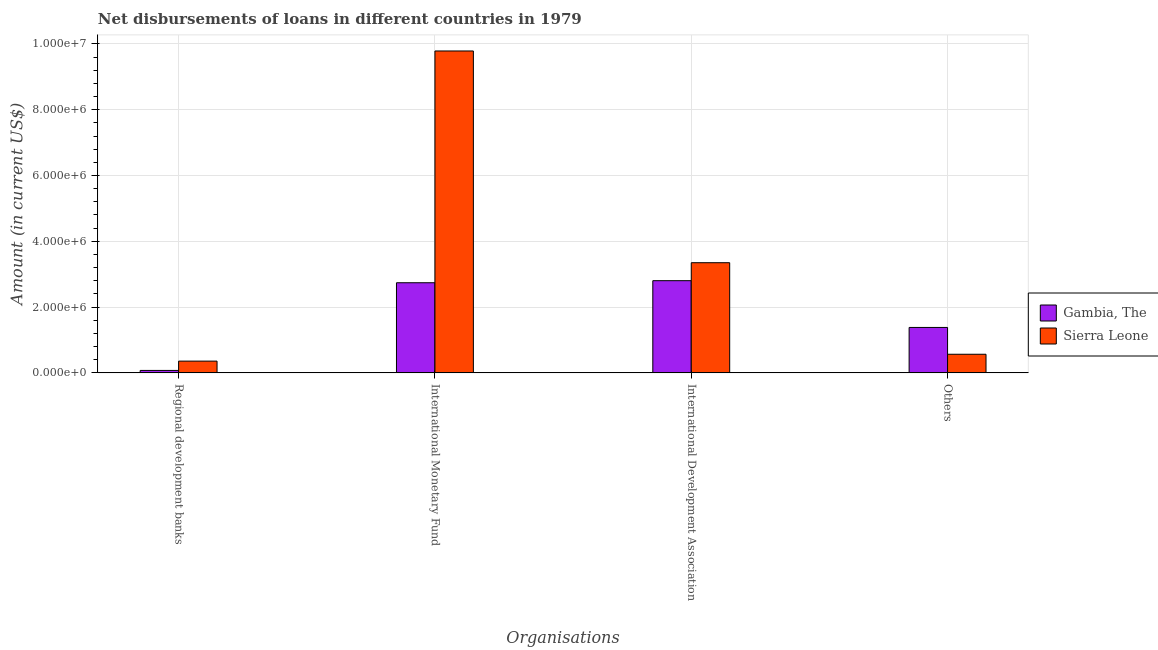Are the number of bars on each tick of the X-axis equal?
Give a very brief answer. Yes. How many bars are there on the 1st tick from the left?
Offer a terse response. 2. What is the label of the 4th group of bars from the left?
Ensure brevity in your answer.  Others. What is the amount of loan disimbursed by regional development banks in Gambia, The?
Your answer should be very brief. 7.40e+04. Across all countries, what is the maximum amount of loan disimbursed by international monetary fund?
Ensure brevity in your answer.  9.79e+06. Across all countries, what is the minimum amount of loan disimbursed by other organisations?
Your answer should be compact. 5.66e+05. In which country was the amount of loan disimbursed by international monetary fund maximum?
Offer a terse response. Sierra Leone. In which country was the amount of loan disimbursed by international monetary fund minimum?
Your response must be concise. Gambia, The. What is the total amount of loan disimbursed by international monetary fund in the graph?
Give a very brief answer. 1.25e+07. What is the difference between the amount of loan disimbursed by international development association in Gambia, The and that in Sierra Leone?
Give a very brief answer. -5.46e+05. What is the difference between the amount of loan disimbursed by international development association in Gambia, The and the amount of loan disimbursed by international monetary fund in Sierra Leone?
Offer a very short reply. -6.98e+06. What is the average amount of loan disimbursed by international development association per country?
Your response must be concise. 3.08e+06. What is the difference between the amount of loan disimbursed by international development association and amount of loan disimbursed by regional development banks in Sierra Leone?
Give a very brief answer. 2.99e+06. What is the ratio of the amount of loan disimbursed by international monetary fund in Gambia, The to that in Sierra Leone?
Ensure brevity in your answer.  0.28. Is the difference between the amount of loan disimbursed by international monetary fund in Sierra Leone and Gambia, The greater than the difference between the amount of loan disimbursed by regional development banks in Sierra Leone and Gambia, The?
Offer a very short reply. Yes. What is the difference between the highest and the second highest amount of loan disimbursed by international monetary fund?
Offer a very short reply. 7.05e+06. What is the difference between the highest and the lowest amount of loan disimbursed by other organisations?
Make the answer very short. 8.15e+05. Is it the case that in every country, the sum of the amount of loan disimbursed by regional development banks and amount of loan disimbursed by international monetary fund is greater than the sum of amount of loan disimbursed by other organisations and amount of loan disimbursed by international development association?
Give a very brief answer. Yes. What does the 2nd bar from the left in Others represents?
Offer a very short reply. Sierra Leone. What does the 1st bar from the right in Others represents?
Offer a very short reply. Sierra Leone. How many bars are there?
Give a very brief answer. 8. Are the values on the major ticks of Y-axis written in scientific E-notation?
Keep it short and to the point. Yes. How many legend labels are there?
Your response must be concise. 2. What is the title of the graph?
Your answer should be compact. Net disbursements of loans in different countries in 1979. Does "Panama" appear as one of the legend labels in the graph?
Give a very brief answer. No. What is the label or title of the X-axis?
Give a very brief answer. Organisations. What is the label or title of the Y-axis?
Make the answer very short. Amount (in current US$). What is the Amount (in current US$) in Gambia, The in Regional development banks?
Your answer should be very brief. 7.40e+04. What is the Amount (in current US$) of Sierra Leone in Regional development banks?
Offer a very short reply. 3.57e+05. What is the Amount (in current US$) in Gambia, The in International Monetary Fund?
Make the answer very short. 2.74e+06. What is the Amount (in current US$) of Sierra Leone in International Monetary Fund?
Offer a very short reply. 9.79e+06. What is the Amount (in current US$) in Gambia, The in International Development Association?
Your answer should be very brief. 2.80e+06. What is the Amount (in current US$) in Sierra Leone in International Development Association?
Offer a very short reply. 3.35e+06. What is the Amount (in current US$) of Gambia, The in Others?
Your answer should be compact. 1.38e+06. What is the Amount (in current US$) in Sierra Leone in Others?
Your response must be concise. 5.66e+05. Across all Organisations, what is the maximum Amount (in current US$) of Gambia, The?
Your response must be concise. 2.80e+06. Across all Organisations, what is the maximum Amount (in current US$) in Sierra Leone?
Make the answer very short. 9.79e+06. Across all Organisations, what is the minimum Amount (in current US$) in Gambia, The?
Offer a terse response. 7.40e+04. Across all Organisations, what is the minimum Amount (in current US$) in Sierra Leone?
Your answer should be compact. 3.57e+05. What is the total Amount (in current US$) of Gambia, The in the graph?
Provide a short and direct response. 7.00e+06. What is the total Amount (in current US$) in Sierra Leone in the graph?
Give a very brief answer. 1.41e+07. What is the difference between the Amount (in current US$) of Gambia, The in Regional development banks and that in International Monetary Fund?
Keep it short and to the point. -2.67e+06. What is the difference between the Amount (in current US$) of Sierra Leone in Regional development banks and that in International Monetary Fund?
Your answer should be very brief. -9.43e+06. What is the difference between the Amount (in current US$) of Gambia, The in Regional development banks and that in International Development Association?
Offer a terse response. -2.73e+06. What is the difference between the Amount (in current US$) in Sierra Leone in Regional development banks and that in International Development Association?
Make the answer very short. -2.99e+06. What is the difference between the Amount (in current US$) in Gambia, The in Regional development banks and that in Others?
Keep it short and to the point. -1.31e+06. What is the difference between the Amount (in current US$) in Sierra Leone in Regional development banks and that in Others?
Your answer should be very brief. -2.09e+05. What is the difference between the Amount (in current US$) of Gambia, The in International Monetary Fund and that in International Development Association?
Provide a succinct answer. -6.30e+04. What is the difference between the Amount (in current US$) in Sierra Leone in International Monetary Fund and that in International Development Association?
Ensure brevity in your answer.  6.44e+06. What is the difference between the Amount (in current US$) of Gambia, The in International Monetary Fund and that in Others?
Your answer should be very brief. 1.36e+06. What is the difference between the Amount (in current US$) of Sierra Leone in International Monetary Fund and that in Others?
Keep it short and to the point. 9.22e+06. What is the difference between the Amount (in current US$) in Gambia, The in International Development Association and that in Others?
Your answer should be very brief. 1.42e+06. What is the difference between the Amount (in current US$) in Sierra Leone in International Development Association and that in Others?
Give a very brief answer. 2.78e+06. What is the difference between the Amount (in current US$) in Gambia, The in Regional development banks and the Amount (in current US$) in Sierra Leone in International Monetary Fund?
Ensure brevity in your answer.  -9.71e+06. What is the difference between the Amount (in current US$) of Gambia, The in Regional development banks and the Amount (in current US$) of Sierra Leone in International Development Association?
Provide a succinct answer. -3.28e+06. What is the difference between the Amount (in current US$) of Gambia, The in Regional development banks and the Amount (in current US$) of Sierra Leone in Others?
Provide a short and direct response. -4.92e+05. What is the difference between the Amount (in current US$) of Gambia, The in International Monetary Fund and the Amount (in current US$) of Sierra Leone in International Development Association?
Provide a short and direct response. -6.09e+05. What is the difference between the Amount (in current US$) of Gambia, The in International Monetary Fund and the Amount (in current US$) of Sierra Leone in Others?
Your answer should be very brief. 2.17e+06. What is the difference between the Amount (in current US$) in Gambia, The in International Development Association and the Amount (in current US$) in Sierra Leone in Others?
Give a very brief answer. 2.24e+06. What is the average Amount (in current US$) of Gambia, The per Organisations?
Ensure brevity in your answer.  1.75e+06. What is the average Amount (in current US$) in Sierra Leone per Organisations?
Ensure brevity in your answer.  3.51e+06. What is the difference between the Amount (in current US$) in Gambia, The and Amount (in current US$) in Sierra Leone in Regional development banks?
Your response must be concise. -2.83e+05. What is the difference between the Amount (in current US$) of Gambia, The and Amount (in current US$) of Sierra Leone in International Monetary Fund?
Keep it short and to the point. -7.05e+06. What is the difference between the Amount (in current US$) in Gambia, The and Amount (in current US$) in Sierra Leone in International Development Association?
Offer a terse response. -5.46e+05. What is the difference between the Amount (in current US$) of Gambia, The and Amount (in current US$) of Sierra Leone in Others?
Your response must be concise. 8.15e+05. What is the ratio of the Amount (in current US$) of Gambia, The in Regional development banks to that in International Monetary Fund?
Make the answer very short. 0.03. What is the ratio of the Amount (in current US$) of Sierra Leone in Regional development banks to that in International Monetary Fund?
Provide a succinct answer. 0.04. What is the ratio of the Amount (in current US$) of Gambia, The in Regional development banks to that in International Development Association?
Give a very brief answer. 0.03. What is the ratio of the Amount (in current US$) in Sierra Leone in Regional development banks to that in International Development Association?
Provide a short and direct response. 0.11. What is the ratio of the Amount (in current US$) in Gambia, The in Regional development banks to that in Others?
Keep it short and to the point. 0.05. What is the ratio of the Amount (in current US$) of Sierra Leone in Regional development banks to that in Others?
Keep it short and to the point. 0.63. What is the ratio of the Amount (in current US$) of Gambia, The in International Monetary Fund to that in International Development Association?
Your answer should be very brief. 0.98. What is the ratio of the Amount (in current US$) in Sierra Leone in International Monetary Fund to that in International Development Association?
Keep it short and to the point. 2.92. What is the ratio of the Amount (in current US$) in Gambia, The in International Monetary Fund to that in Others?
Offer a terse response. 1.98. What is the ratio of the Amount (in current US$) in Sierra Leone in International Monetary Fund to that in Others?
Give a very brief answer. 17.29. What is the ratio of the Amount (in current US$) of Gambia, The in International Development Association to that in Others?
Your response must be concise. 2.03. What is the ratio of the Amount (in current US$) in Sierra Leone in International Development Association to that in Others?
Your answer should be very brief. 5.92. What is the difference between the highest and the second highest Amount (in current US$) of Gambia, The?
Provide a short and direct response. 6.30e+04. What is the difference between the highest and the second highest Amount (in current US$) of Sierra Leone?
Offer a terse response. 6.44e+06. What is the difference between the highest and the lowest Amount (in current US$) of Gambia, The?
Give a very brief answer. 2.73e+06. What is the difference between the highest and the lowest Amount (in current US$) of Sierra Leone?
Your response must be concise. 9.43e+06. 